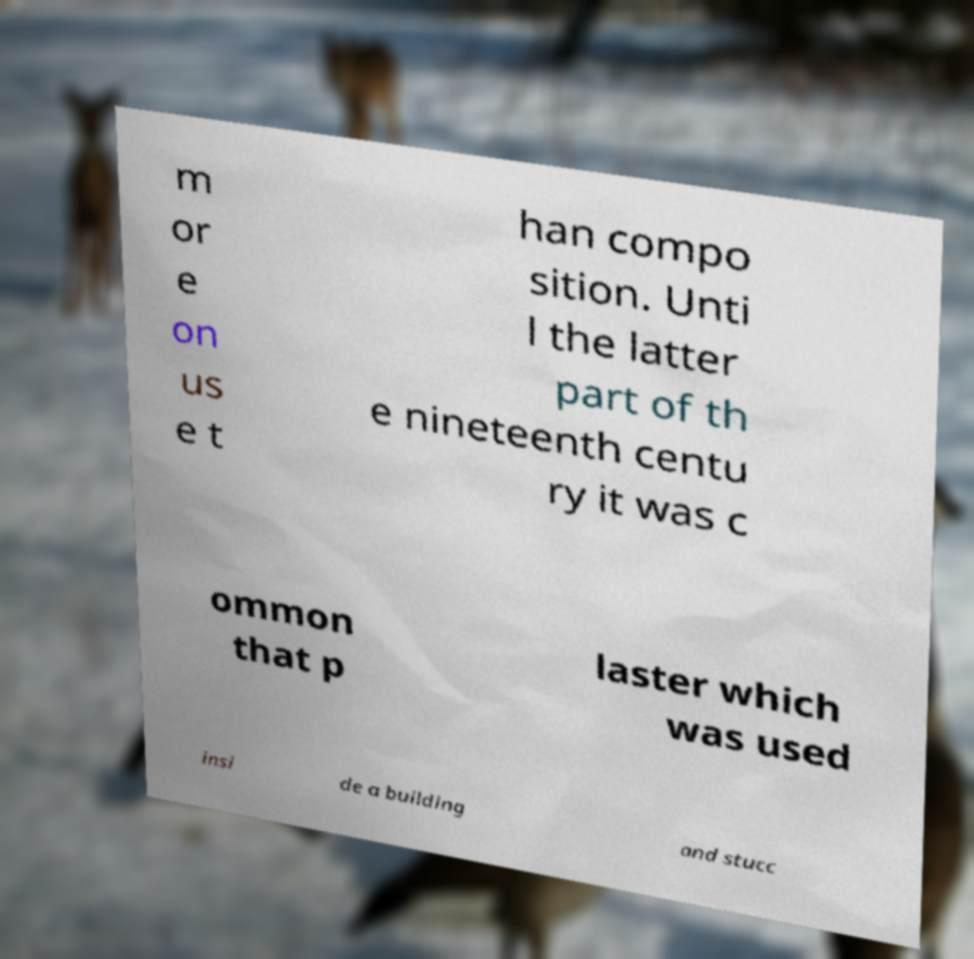Please read and relay the text visible in this image. What does it say? m or e on us e t han compo sition. Unti l the latter part of th e nineteenth centu ry it was c ommon that p laster which was used insi de a building and stucc 